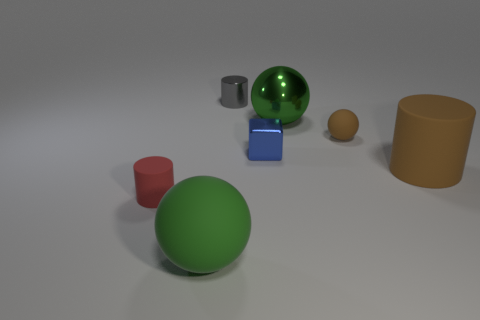Subtract all brown spheres. Subtract all green cylinders. How many spheres are left? 2 Add 1 big green rubber cylinders. How many objects exist? 8 Subtract all cubes. How many objects are left? 6 Subtract 0 yellow blocks. How many objects are left? 7 Subtract all small things. Subtract all big red cubes. How many objects are left? 3 Add 4 gray cylinders. How many gray cylinders are left? 5 Add 6 metal balls. How many metal balls exist? 7 